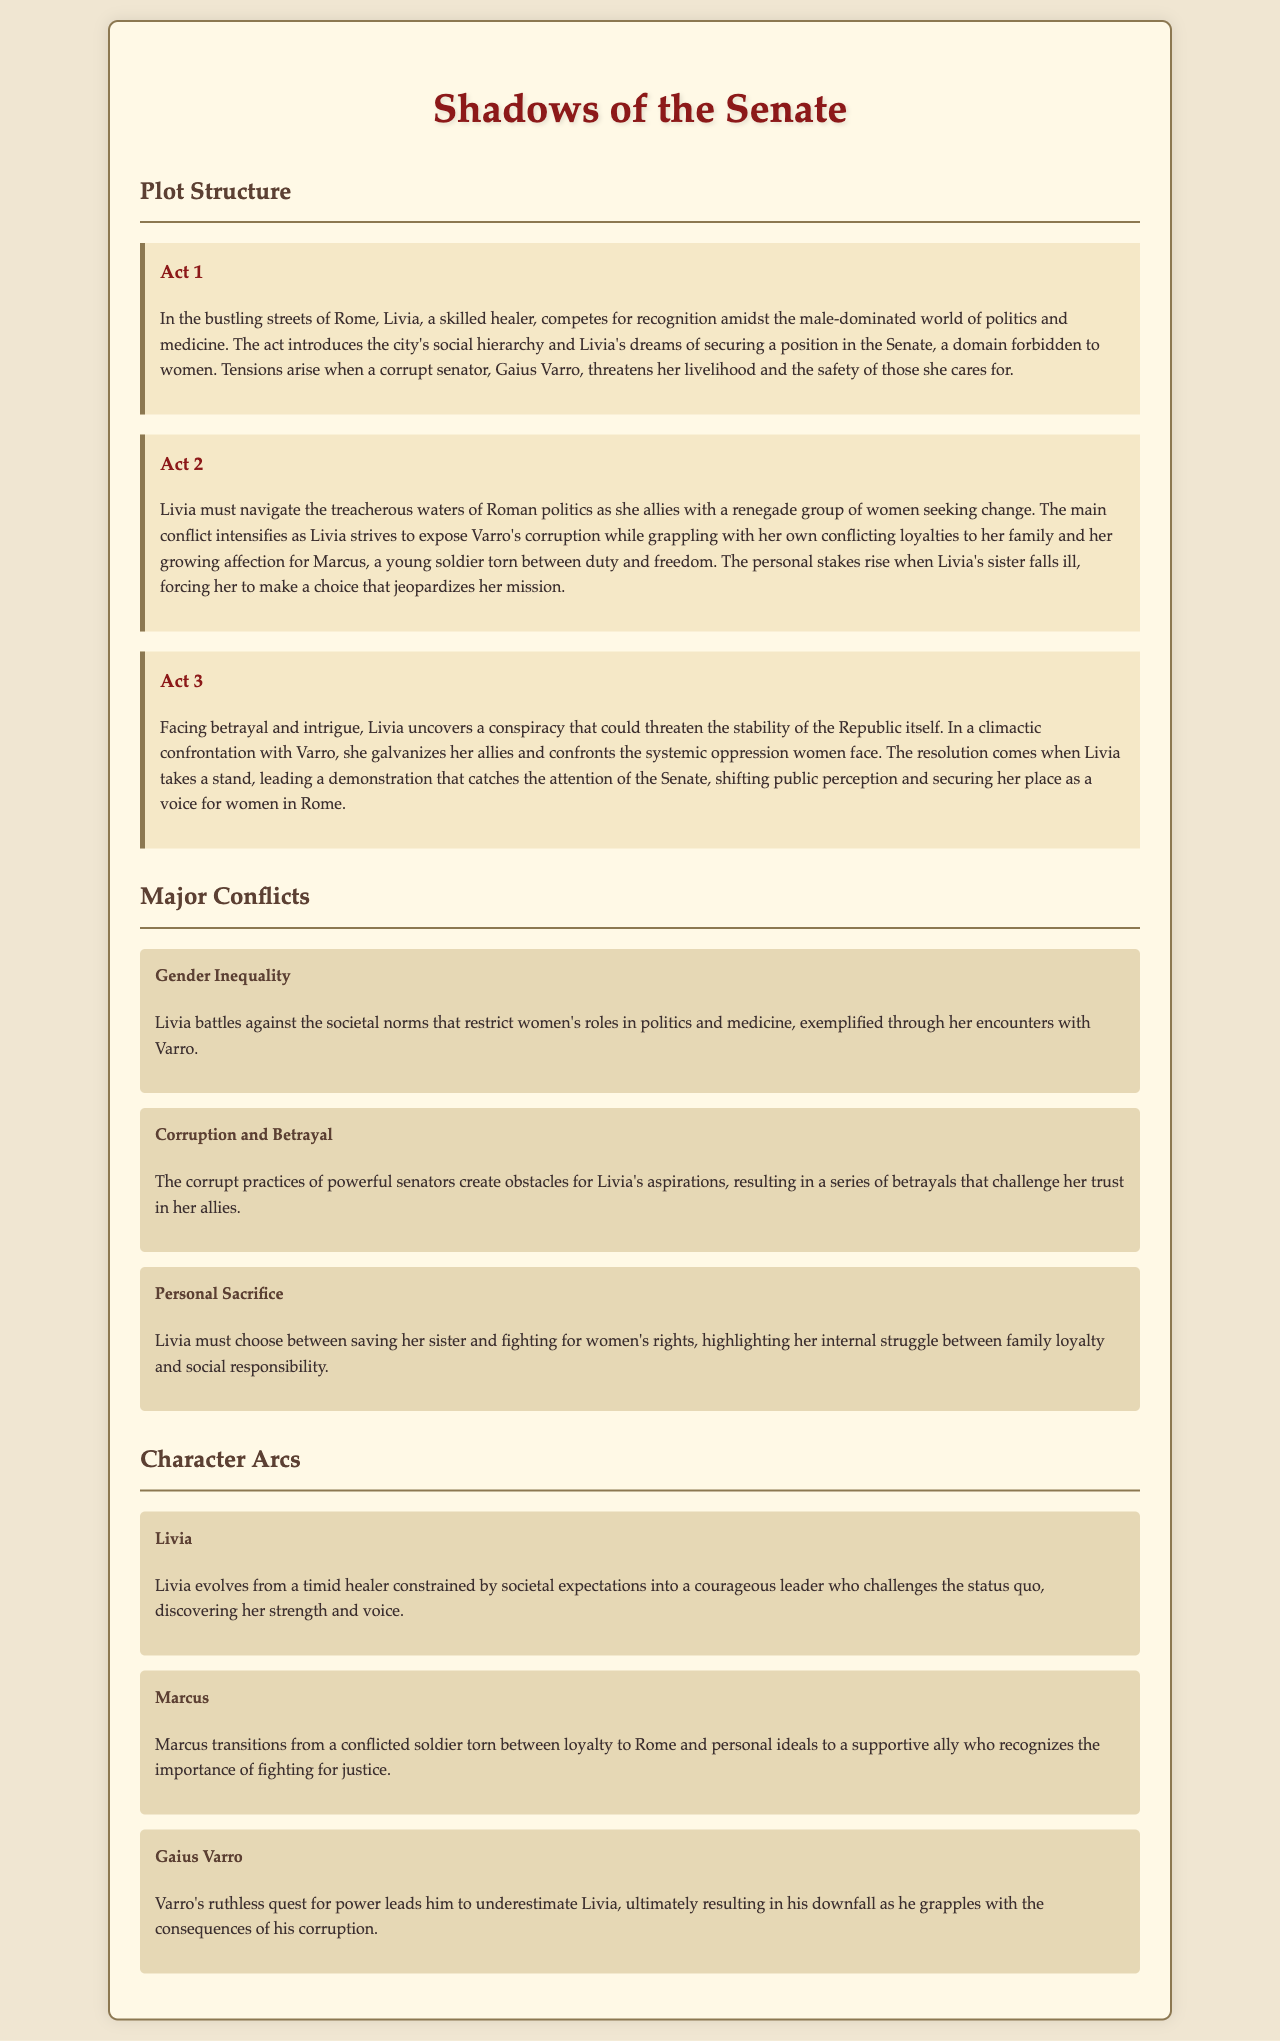What is the title of the novel? The title is mentioned in the header of the document, prominently displayed.
Answer: Shadows of the Senate Who is the protagonist of the story? The protagonist is introduced in the first act of the novel.
Answer: Livia What is the main conflict in Act 1? The main conflict involves Livia's struggles against a corrupt senator.
Answer: Gaius Varro What personal sacrifice does Livia face? The document outlines a specific dilemma Livia must confront regarding family versus mission.
Answer: Saving her sister How does Livia's character evolve throughout the story? The character arc details Livia's transformation from a healer to a leader.
Answer: Courageous leader Who is a supporting character in the novel? A character involved in Livia's journey is noted in the character arcs section.
Answer: Marcus What is the climax of the story? The climax involves a confrontation that highlights systemic oppression faced by women.
Answer: Confrontation with Varro What societal issue does Livia fight against? One of the major conflicts outlined directly relates to societal norms.
Answer: Gender Inequality What motivates Marcus's transition in the story? The document describes Marcus's journey from conflict to support, revealing his motivation.
Answer: Fighting for justice 